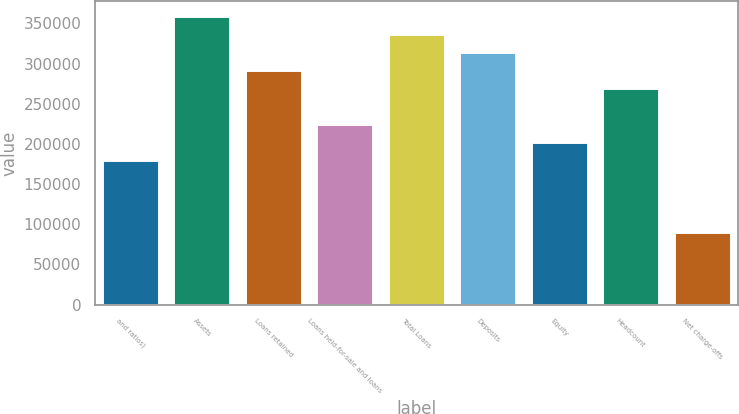Convert chart. <chart><loc_0><loc_0><loc_500><loc_500><bar_chart><fcel>and ratios)<fcel>Assets<fcel>Loans retained<fcel>Loans held-for-sale and loans<fcel>Total Loans<fcel>Deposits<fcel>Equity<fcel>Headcount<fcel>Net charge-offs<nl><fcel>179841<fcel>359681<fcel>292241<fcel>224801<fcel>337201<fcel>314721<fcel>202321<fcel>269761<fcel>89920.6<nl></chart> 